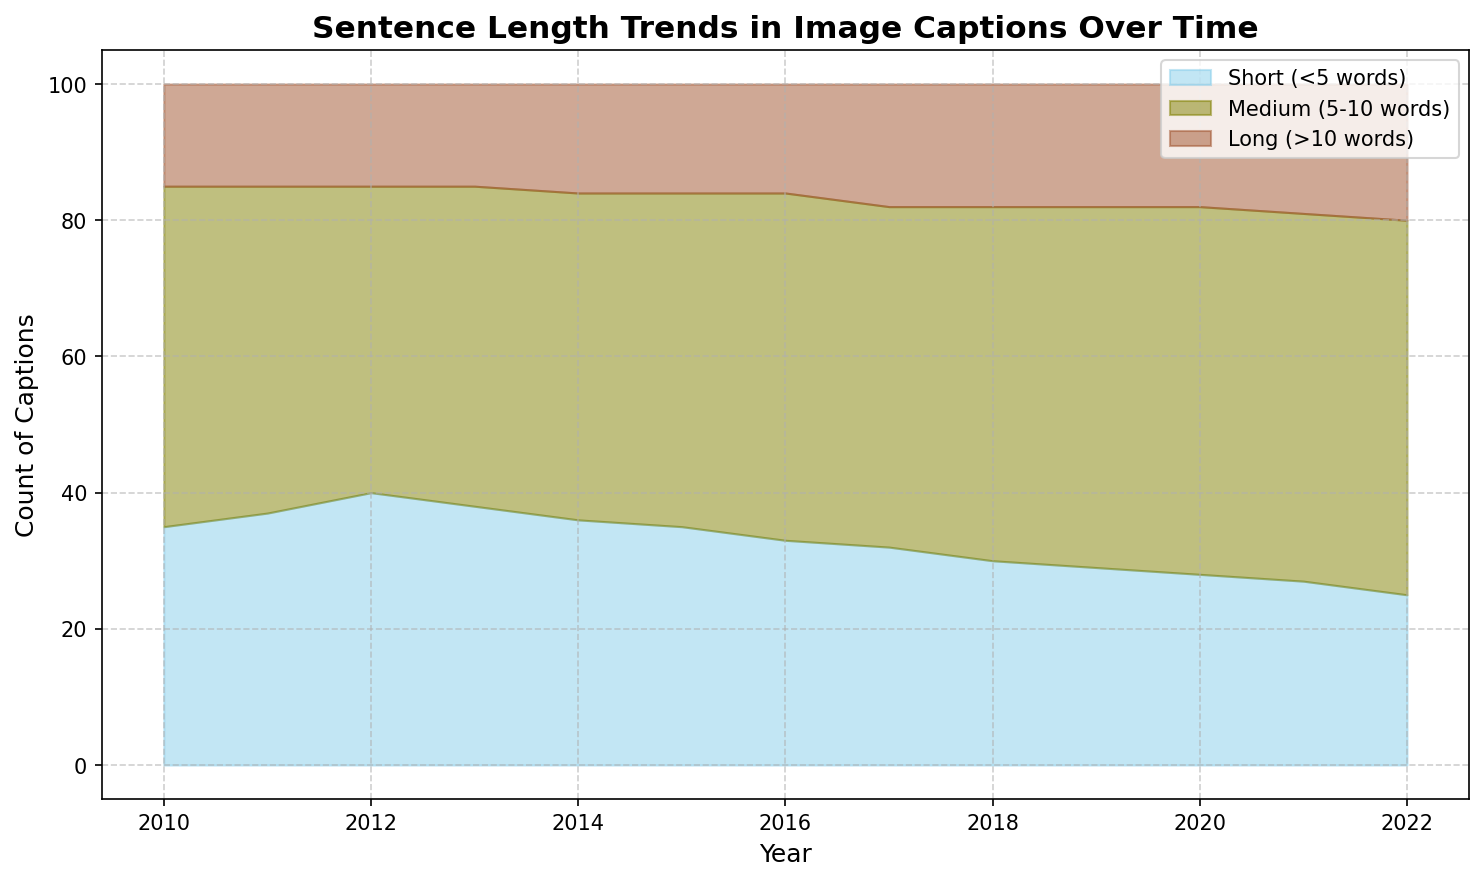What is the general trend in the number of short sentences (<5 words) over the years? From 2010 to 2022, the number of short sentences decreased gradually each year.
Answer: Decreasing What was the difference in the number of medium sentences (5-10 words) between 2010 and 2022? In 2010, there were 50 medium sentences; in 2022, there were 55. The difference is 55 - 50.
Answer: 5 How do the trends in medium sentences (5-10 words) and long sentences (>10 words) compare from 2010 to 2022? Both medium and long sentences show an increasing trend over the years. Medium sentences increased steadily, whereas long sentences had a slightly more gradual increase.
Answer: Both increasing What is the percentage increase in long sentences (>10 words) from 2010 to 2022? In 2010, there were 15 long sentences; in 2022, there were 20. The percentage increase is calculated as ((20 - 15) / 15) * 100%.
Answer: 33.33% What year had the highest overall count of sentences? To find the highest overall count, sum the values of short, medium, and long sentences for each year, and compare. In 2022, the total count is 25+55+20 = 100, which is the highest.
Answer: 2022 What visual attribute distinguishes medium-length sentence counts in the chart? Medium-length sentences are represented by the olive fill color.
Answer: Olive How did the count of short sentences change from 2018 to 2022? In 2018, there were 30 short sentences; in 2022, there were 25. The count decreased by 30 - 25.
Answer: Decreased by 5 Which category saw the least change in sentence counts over the years? Long sentences remained relatively stable, starting at 15 in 2010 and slowly rising to 20 in 2022, representing the smallest change compared to the other categories.
Answer: Long sentences Which year had an equal count of short and long sentences? By comparing the provided data, no year had an equal count of short and long sentences.
Answer: None In which year did medium sentences first surpass 50 counts? Medium sentences first surpassed 50 counts in 2017 when the count reached 51.
Answer: 2017 